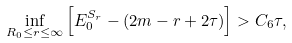<formula> <loc_0><loc_0><loc_500><loc_500>\inf _ { R _ { 0 } \leq r \leq \infty } \left [ E _ { 0 } ^ { S _ { r } } - ( 2 m - r + 2 \tau ) \right ] > C _ { 6 } \tau ,</formula> 